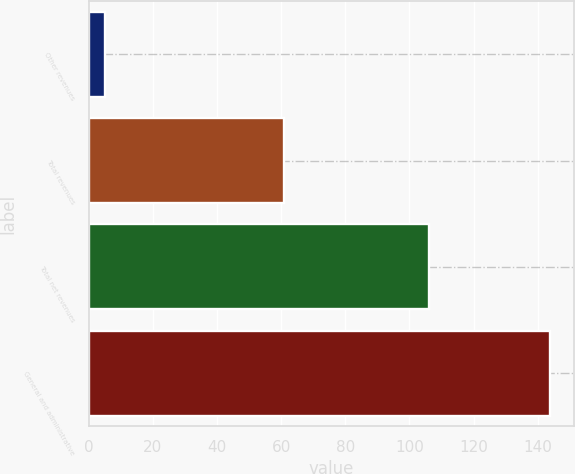<chart> <loc_0><loc_0><loc_500><loc_500><bar_chart><fcel>Other revenues<fcel>Total revenues<fcel>Total net revenues<fcel>General and administrative<nl><fcel>5<fcel>61<fcel>106<fcel>144<nl></chart> 